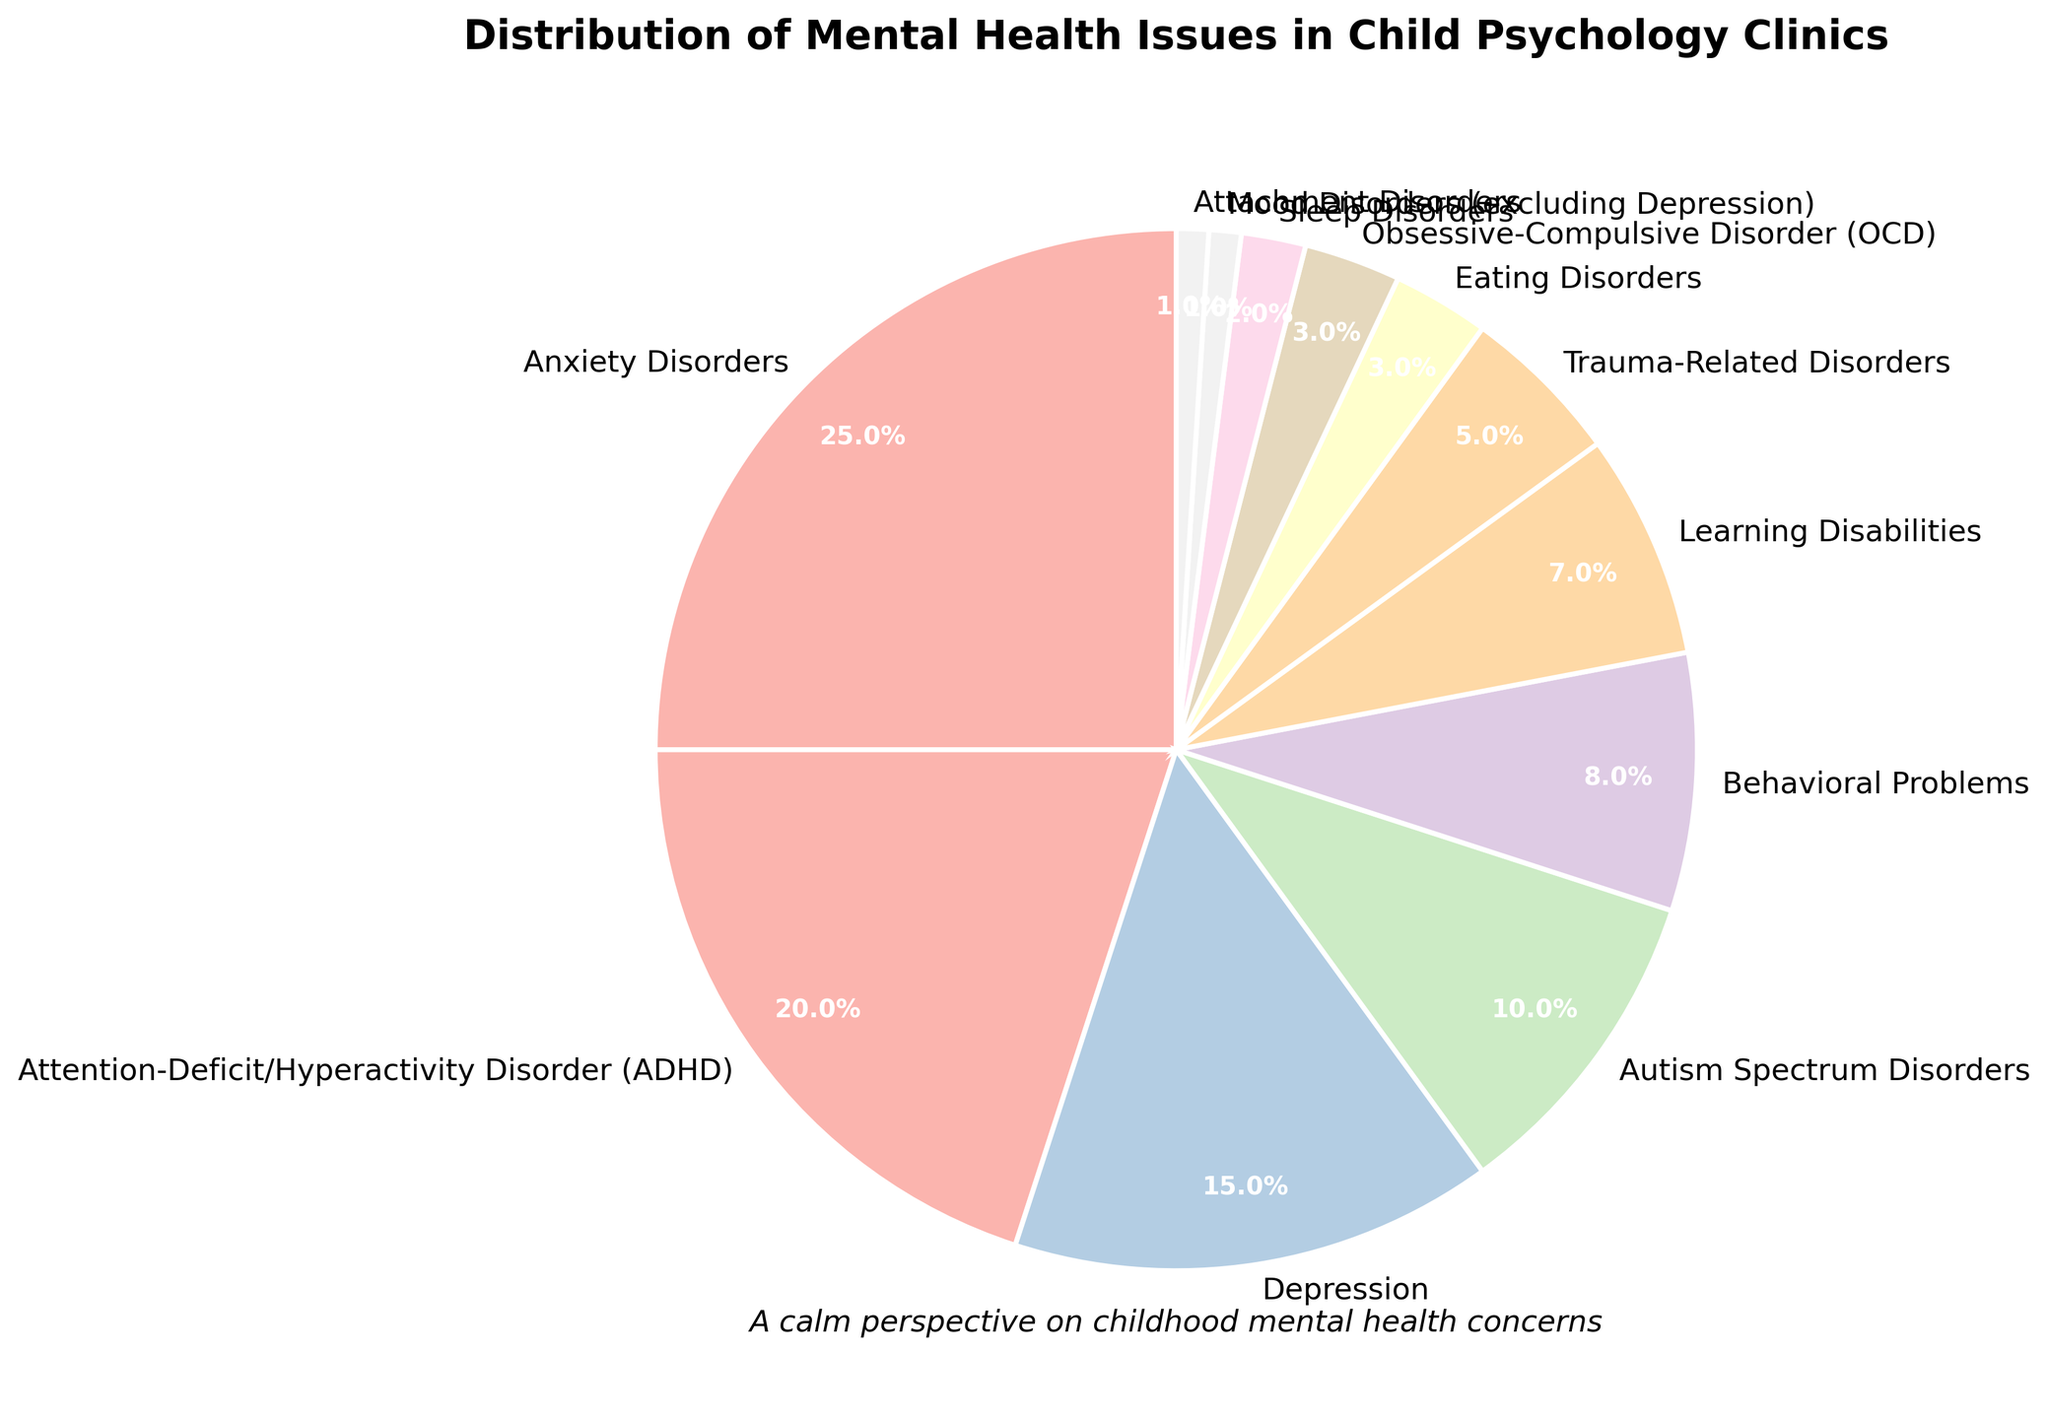What is the most common mental health issue addressed in child psychology clinics? The largest segment on the pie chart represents Anxiety Disorders, which occupies 25% of the chart, indicating it’s the most common issue.
Answer: Anxiety Disorders What two mental health issues together make up 35% of the cases? By looking at the chart, Anxiety Disorders (25%) and ADHD (20%) together make up 45%, but that exceeds 35%. However, Anxiety Disorders (25%) and Depression (15%) make up 40%, which is still over. The correct combination is ADHD (20%) and Depression (15%) totaling 35%.
Answer: ADHD and Depression Which mental health issues individually account for less than 5% of the cases? Observing the smaller slices of the pie chart, Trauma-Related Disorders (5%), Eating Disorders (3%), OCD (3%), Sleep Disorders (2%), Mood Disorders (1%), and Attachment Disorders (1%) all account for less than 5% individually.
Answer: Eating Disorders, OCD, Sleep Disorders, Mood Disorders, Attachment Disorders How much larger is the percentage of cases for ADHD compared to Behavioral Problems? ADHD takes up 20% of the pie chart, while Behavioral Problems represent 8%. The difference is calculated by subtracting the smaller percentage from the larger one (20% - 8%).
Answer: 12% If Anxiety Disorders and ADHD were combined into a single category, what would be their total percentage? Anxiety Disorders occupy 25% and ADHD occupies 20% of the pie chart. Adding these percentages together (25% + 20%) gives the total.
Answer: 45% Are there any mental health issues that occupy the same percentage of the pie chart? Examining the pie chart, we see that Eating Disorders and OCD both have a 3% representation.
Answer: Yes Which segment is visually the smallest on the pie chart? The smallest slices on the pie chart are for Mood Disorders and Attachment Disorders, each representing only 1%, but as a single unit, these are the smallest visually.
Answer: Mood Disorders and Attachment Disorders What percentage of the cases is attributed to disorders on the Autism Spectrum? The pie chart shows the segment labeled Autism Spectrum Disorders occupies 10%.
Answer: 10% 